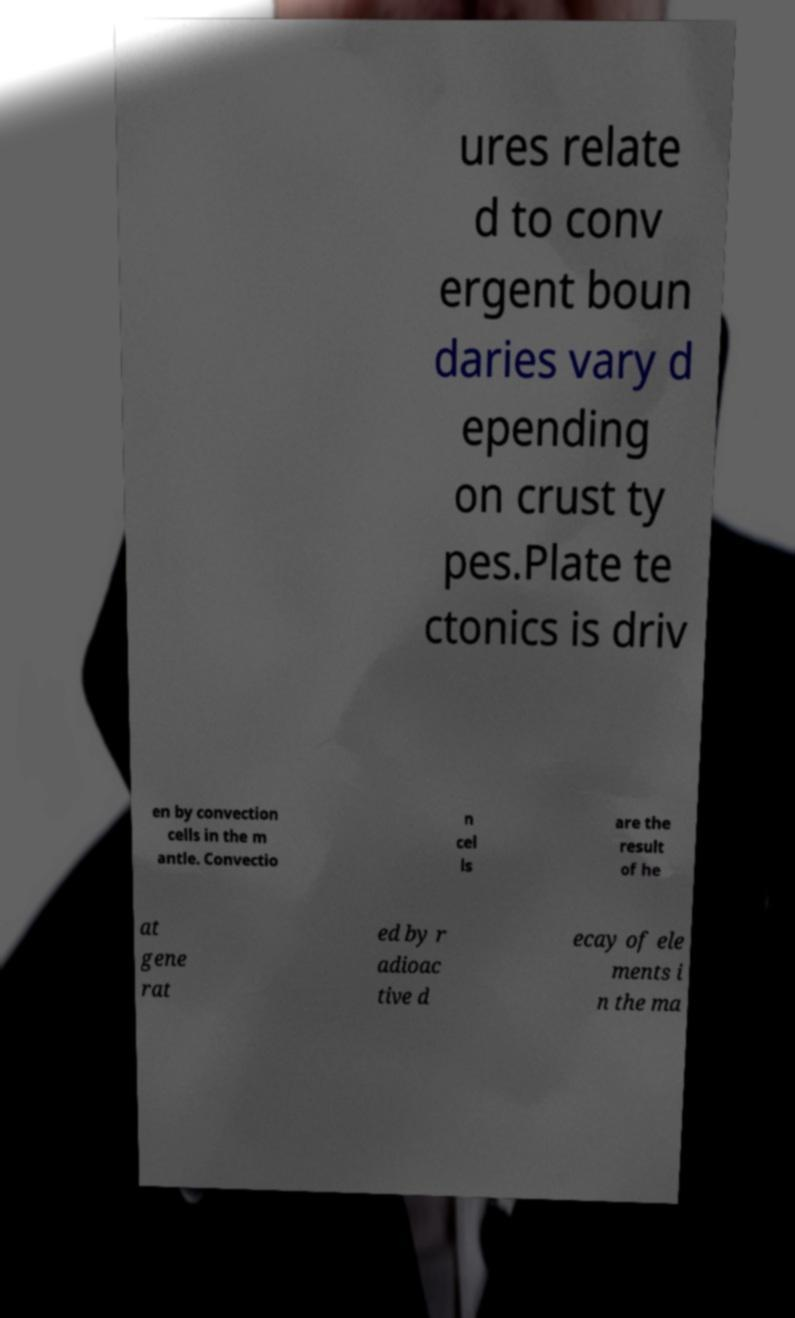I need the written content from this picture converted into text. Can you do that? ures relate d to conv ergent boun daries vary d epending on crust ty pes.Plate te ctonics is driv en by convection cells in the m antle. Convectio n cel ls are the result of he at gene rat ed by r adioac tive d ecay of ele ments i n the ma 